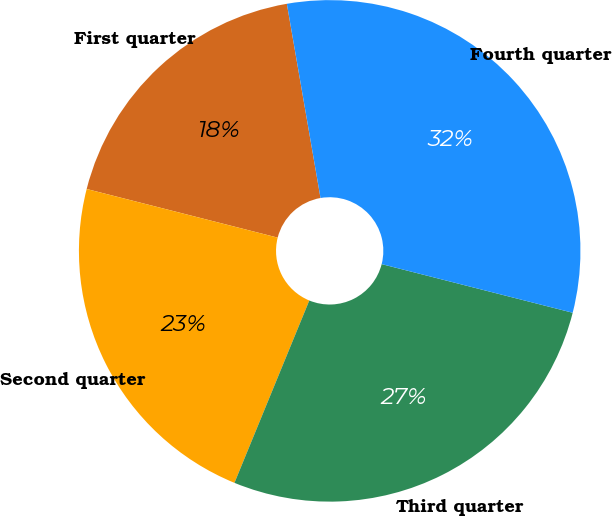Convert chart to OTSL. <chart><loc_0><loc_0><loc_500><loc_500><pie_chart><fcel>First quarter<fcel>Second quarter<fcel>Third quarter<fcel>Fourth quarter<nl><fcel>18.3%<fcel>22.77%<fcel>27.23%<fcel>31.7%<nl></chart> 